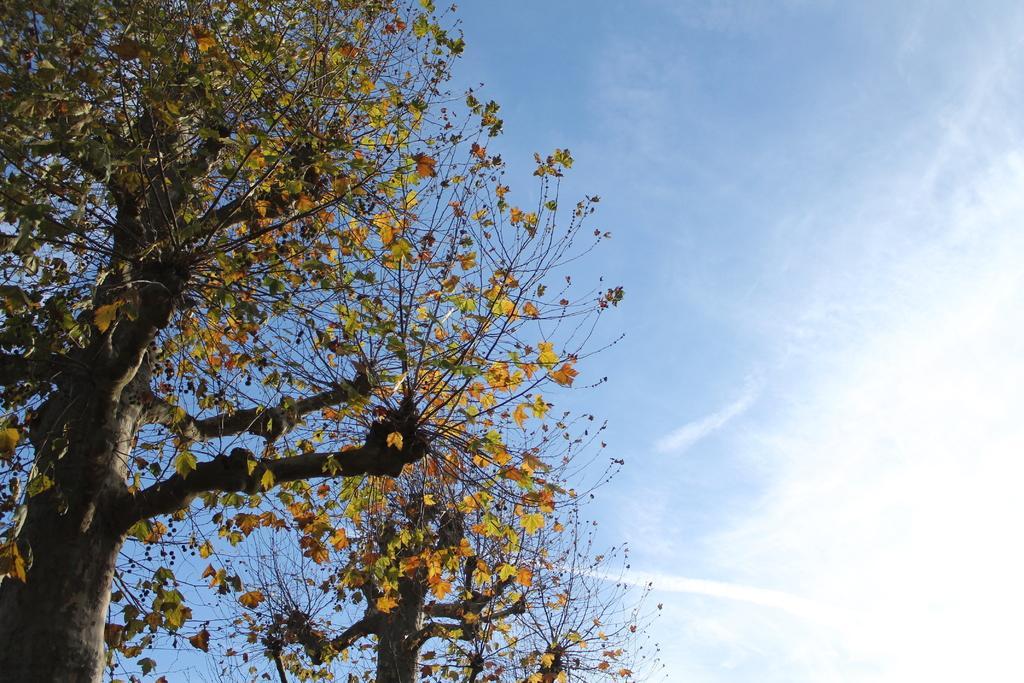Describe this image in one or two sentences. In this image we can see trees and the sky with clouds in the background. 